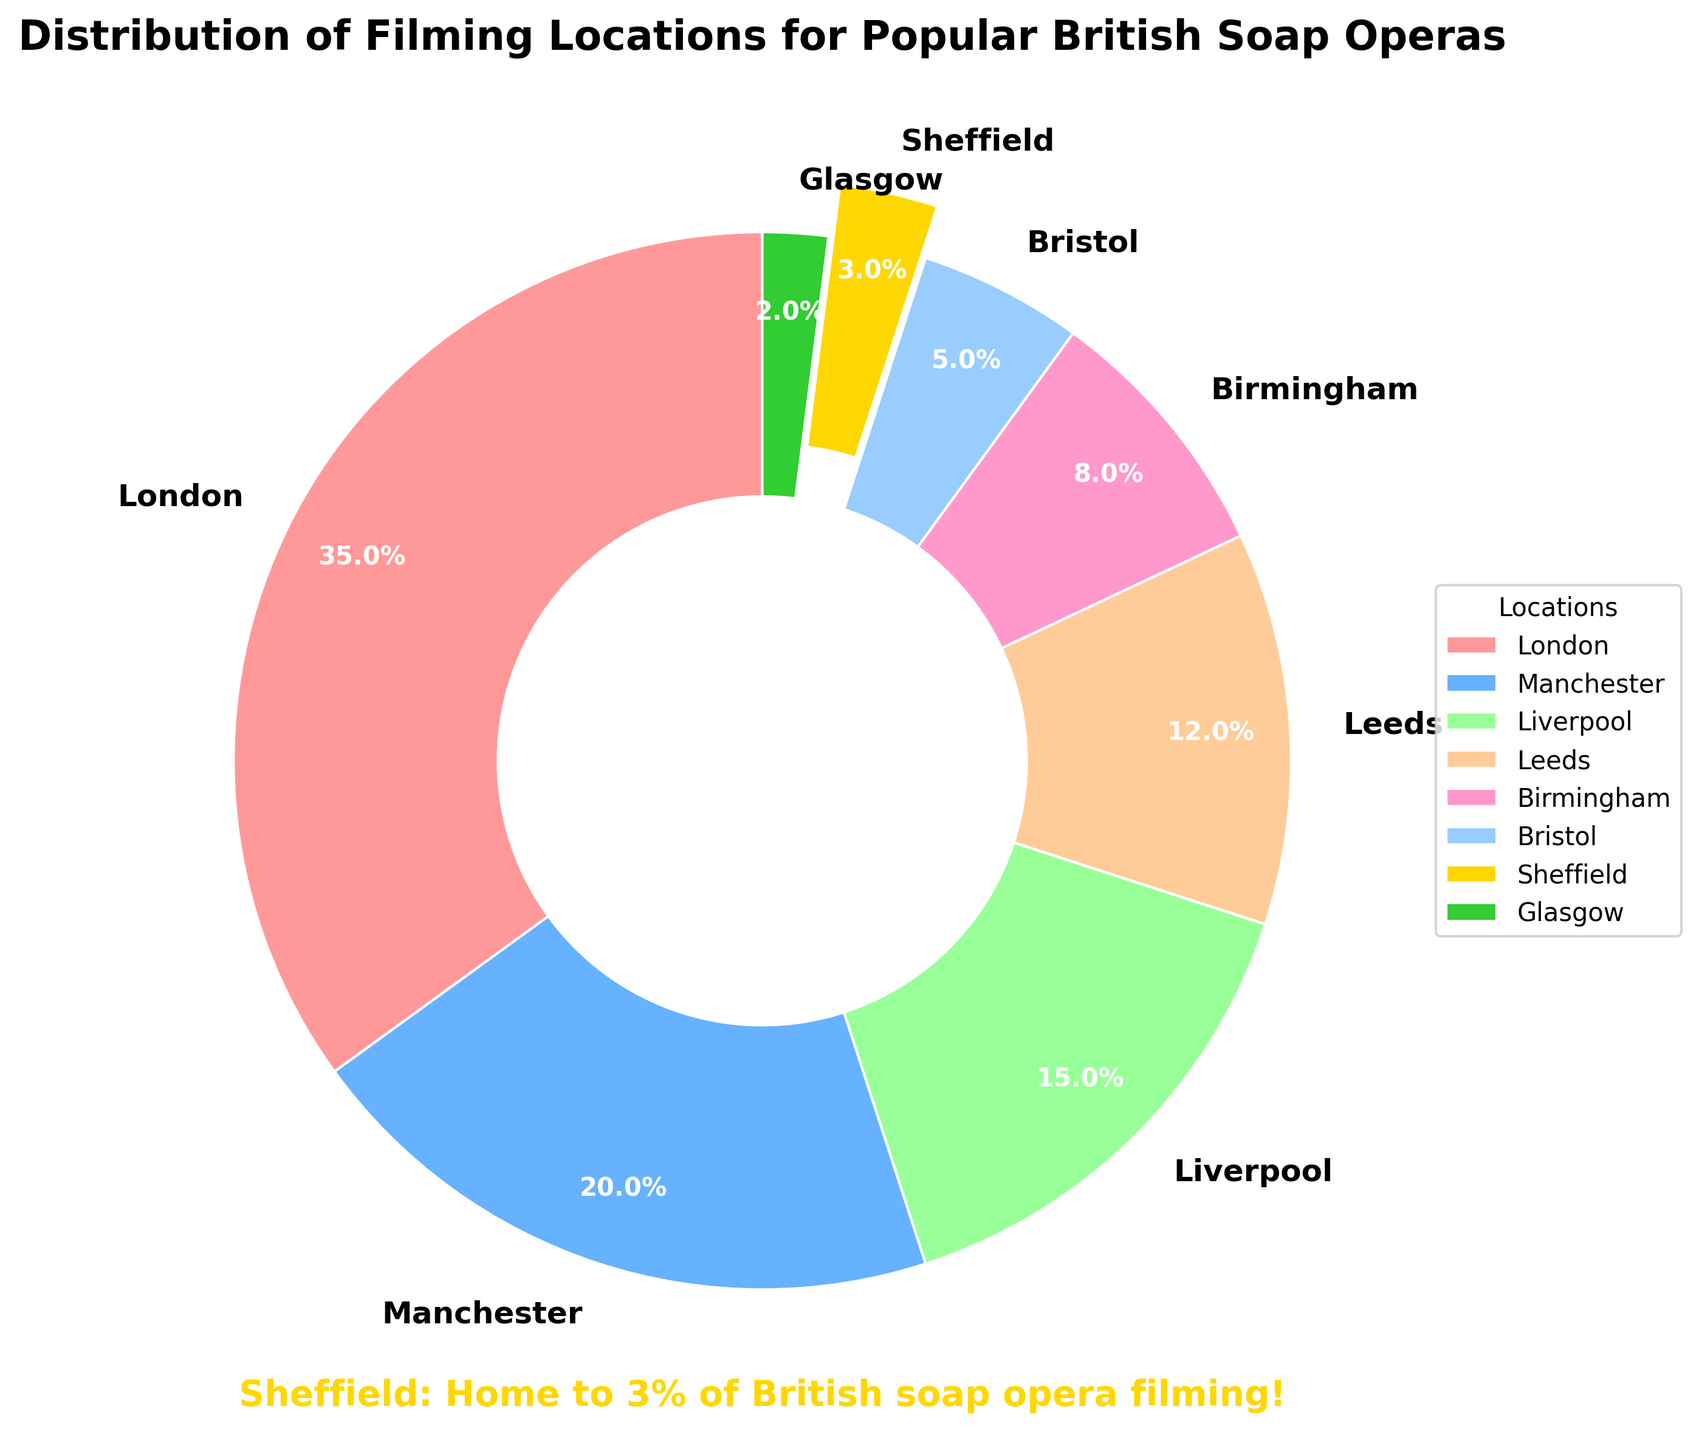Which location has the highest percentage of filming? The largest wedge in the pie chart corresponds to London, which has a label showing 35%.
Answer: London Which locations together make up more than half of the filming locations? By examining the pie chart, London (35%) and Manchester (20%) combined make up 55%, which is more than half.
Answer: London and Manchester How much larger is the percentage of filming in Liverpool compared to Sheffield? Liverpool has 15% and Sheffield has 3%. The difference is 15% - 3% = 12%.
Answer: 12% What is the combined percentage of filming in Birmingham and Bristol? Birmingham has 8% and Bristol has 5%. Adding these gives 8% + 5% = 13%.
Answer: 13% Which location is represented by a gold color and how much filming occurs there? The gold-colored wedge is blown out and represents Sheffield, which accounts for 3%.
Answer: Sheffield, 3% Rank the top three locations in terms of filming percentage. The highest percentages are 35% for London, 20% for Manchester, and 15% for Liverpool, in that order.
Answer: London, Manchester, Liverpool Which location has the smallest share of filming and what is its percentage? The smallest wedge belongs to Glasgow, indicated by the label showing 2%.
Answer: Glasgow, 2% What is the percentage difference in filming between the locations with the least and the most filming? London has the most with 35% and Glasgow the least with 2%. The difference is 35% - 2% = 33%.
Answer: 33% What is the total percentage of filming for Leeds, Birmingham, and Bristol combined? Leeds has 12%, Birmingham has 8%, and Bristol has 5%. Their combined percentage is 12% + 8% + 5% = 25%.
Answer: 25% What is visually unique about the wedge representing Sheffield, and why might this be done? The wedge for Sheffield is exploded (separated from the rest) and highlighted with a gold color. This likely emphasizes its importance or uniqueness, perhaps due to local interest.
Answer: Exploded, gold color 